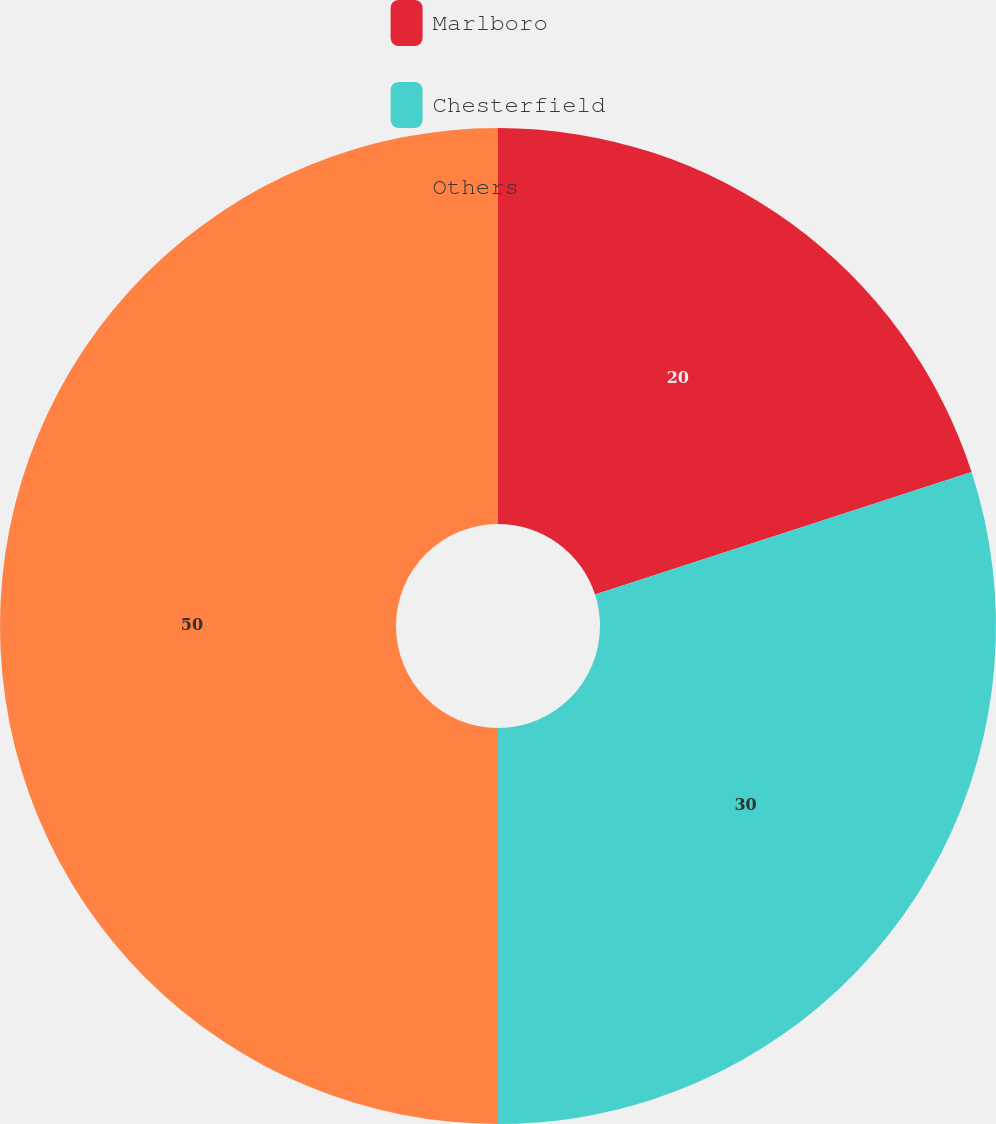Convert chart to OTSL. <chart><loc_0><loc_0><loc_500><loc_500><pie_chart><fcel>Marlboro<fcel>Chesterfield<fcel>Others<nl><fcel>20.0%<fcel>30.0%<fcel>50.0%<nl></chart> 